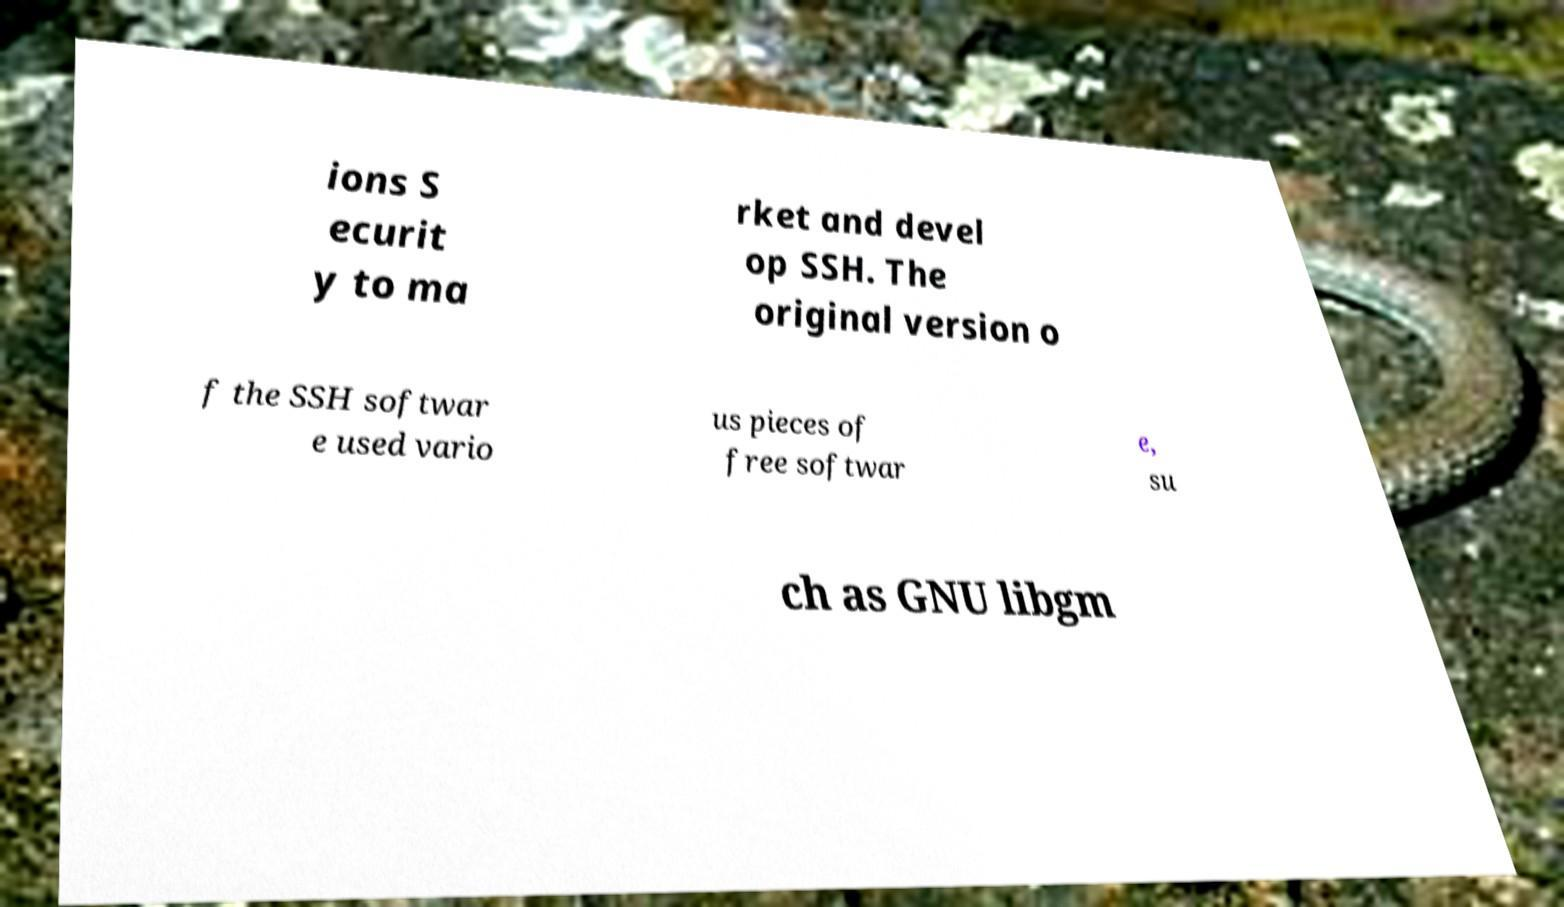Please read and relay the text visible in this image. What does it say? ions S ecurit y to ma rket and devel op SSH. The original version o f the SSH softwar e used vario us pieces of free softwar e, su ch as GNU libgm 